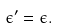<formula> <loc_0><loc_0><loc_500><loc_500>\epsilon ^ { \prime } = \epsilon .</formula> 